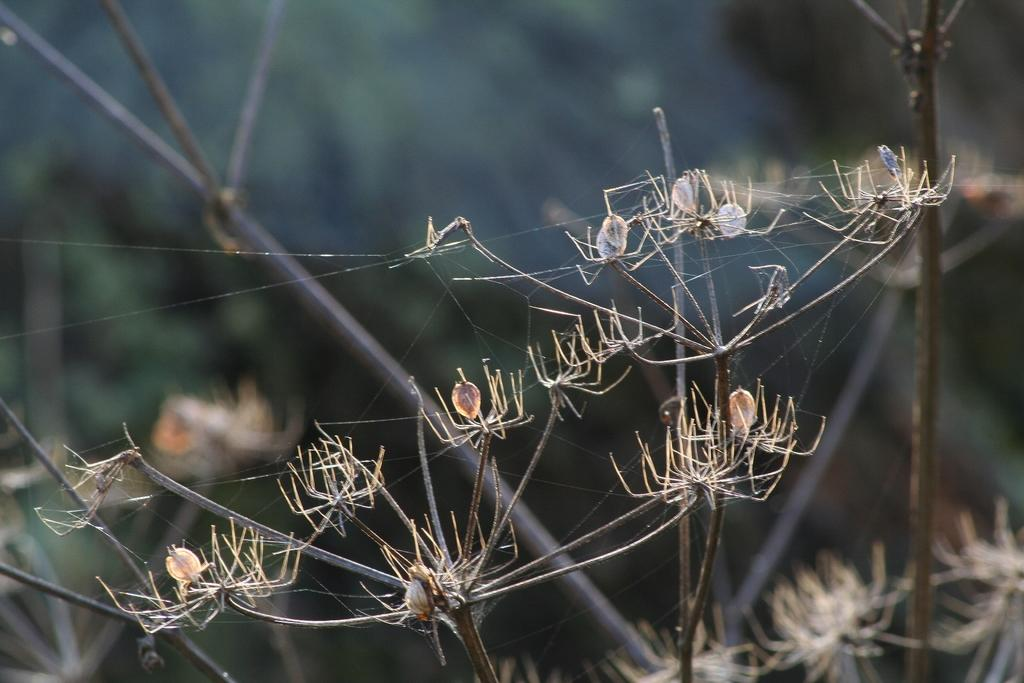What creatures are present in the image? There are spiders in the image. Where are the spiders located? The spiders are on the branches of a tree. How many goldfish can be seen swimming in the branches of the tree in the image? There are no goldfish present in the image; it features spiders on the branches of a tree. What type of decorative item is hanging from the branches of the tree in the image? There is no decorative item, such as a basket or icicle, hanging from the branches of the tree in the image. 